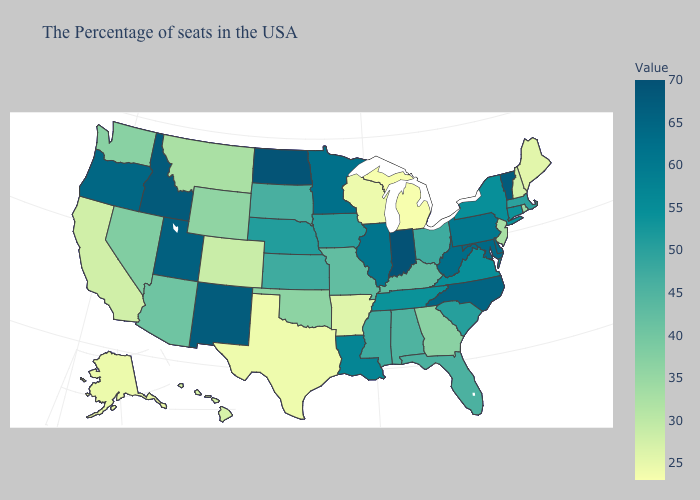Which states have the lowest value in the West?
Answer briefly. Alaska. Does Arizona have the lowest value in the West?
Quick response, please. No. Does Indiana have the highest value in the MidWest?
Quick response, please. Yes. Among the states that border Vermont , which have the highest value?
Quick response, please. New York. Among the states that border Nebraska , which have the lowest value?
Be succinct. Colorado. Among the states that border Louisiana , which have the lowest value?
Keep it brief. Texas. Which states hav the highest value in the Northeast?
Write a very short answer. Vermont. 